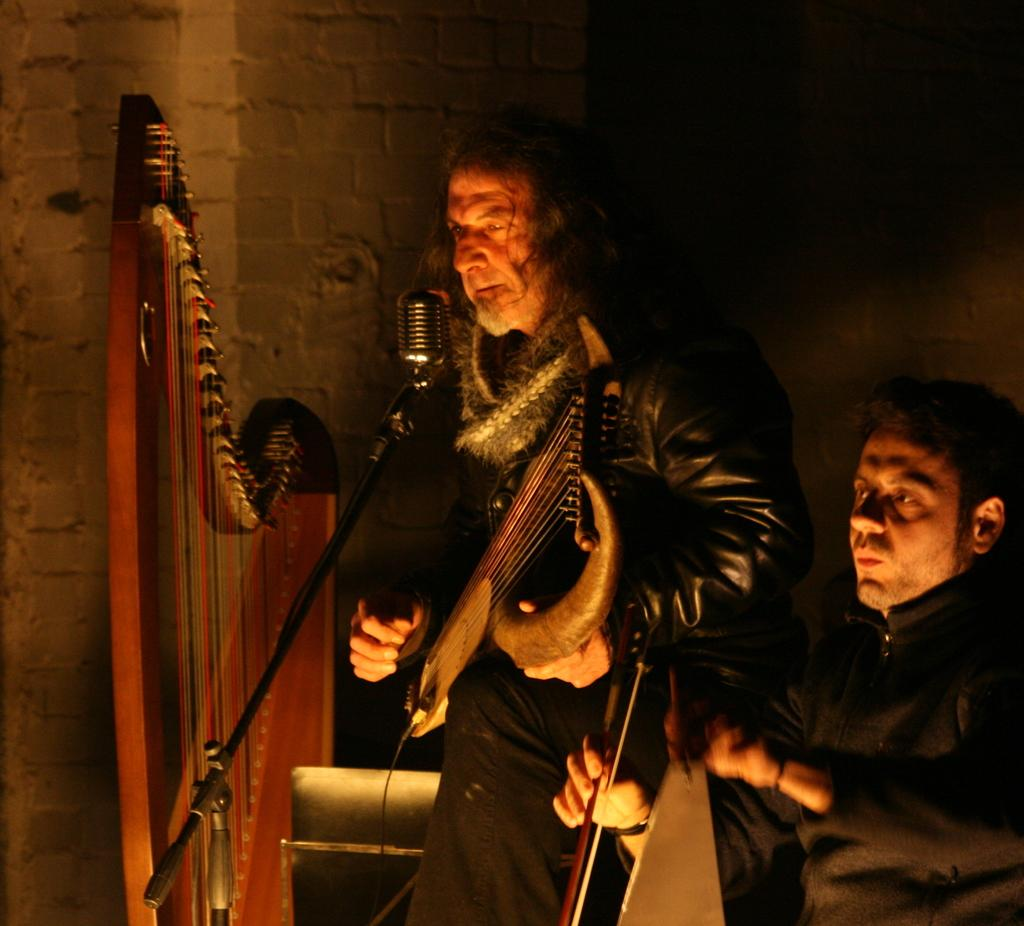How many people are in the image? There are two persons in the image. What are the persons doing in the image? The persons are playing musical instruments. What can be seen in the background of the image? There is a wall in the background of the image. What device is present in the image that might be used for amplifying sound? There is a mic in the image. What type of peace offering is being made by the celery in the image? There is no celery present in the image, so it cannot be making any peace offerings. 